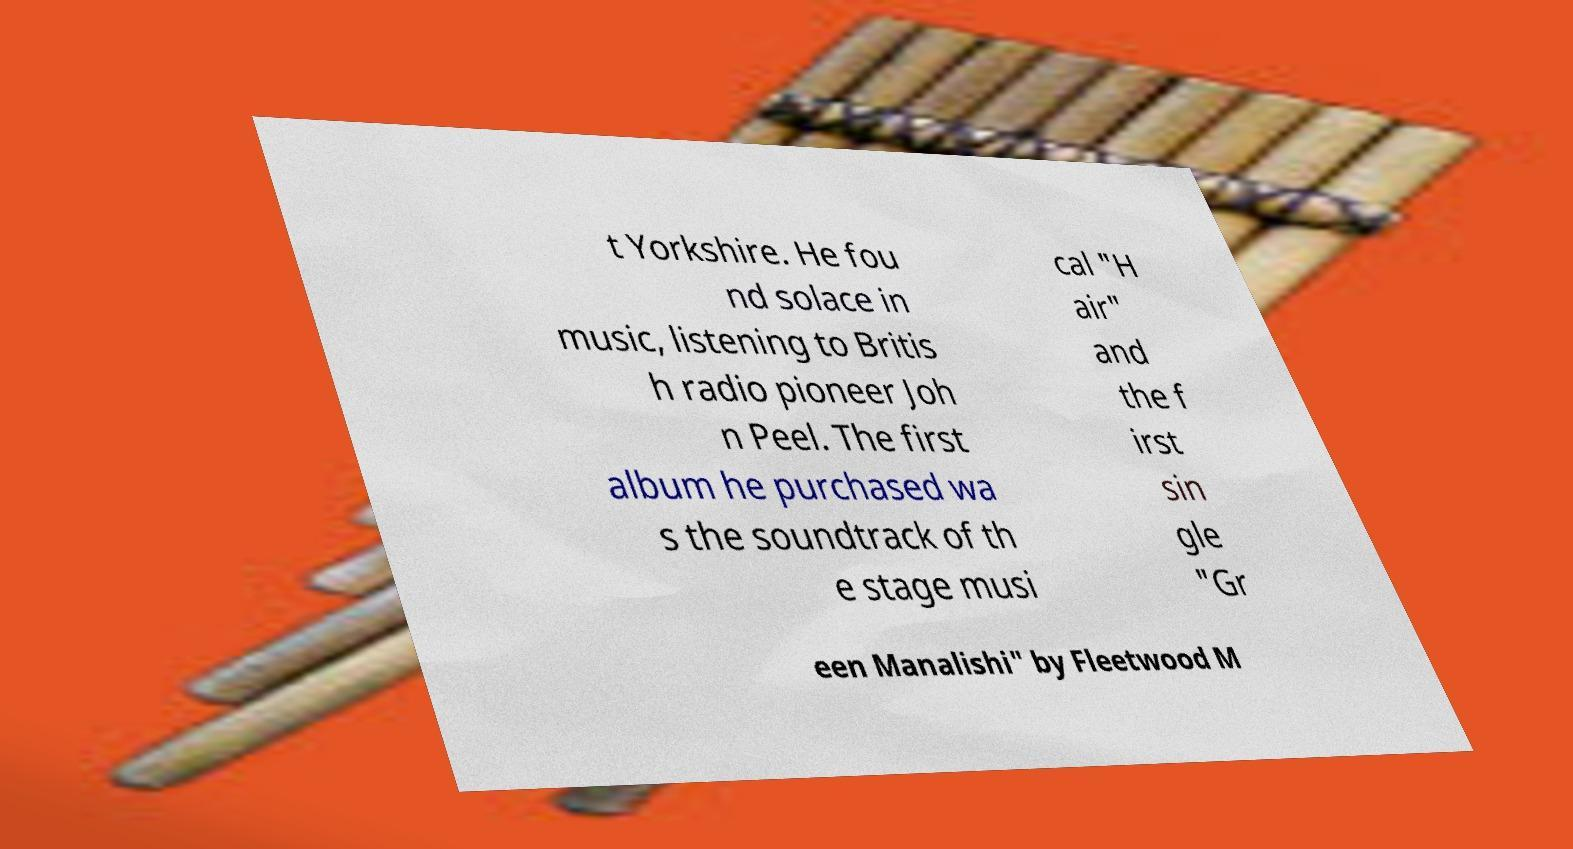What messages or text are displayed in this image? I need them in a readable, typed format. t Yorkshire. He fou nd solace in music, listening to Britis h radio pioneer Joh n Peel. The first album he purchased wa s the soundtrack of th e stage musi cal "H air" and the f irst sin gle "Gr een Manalishi" by Fleetwood M 